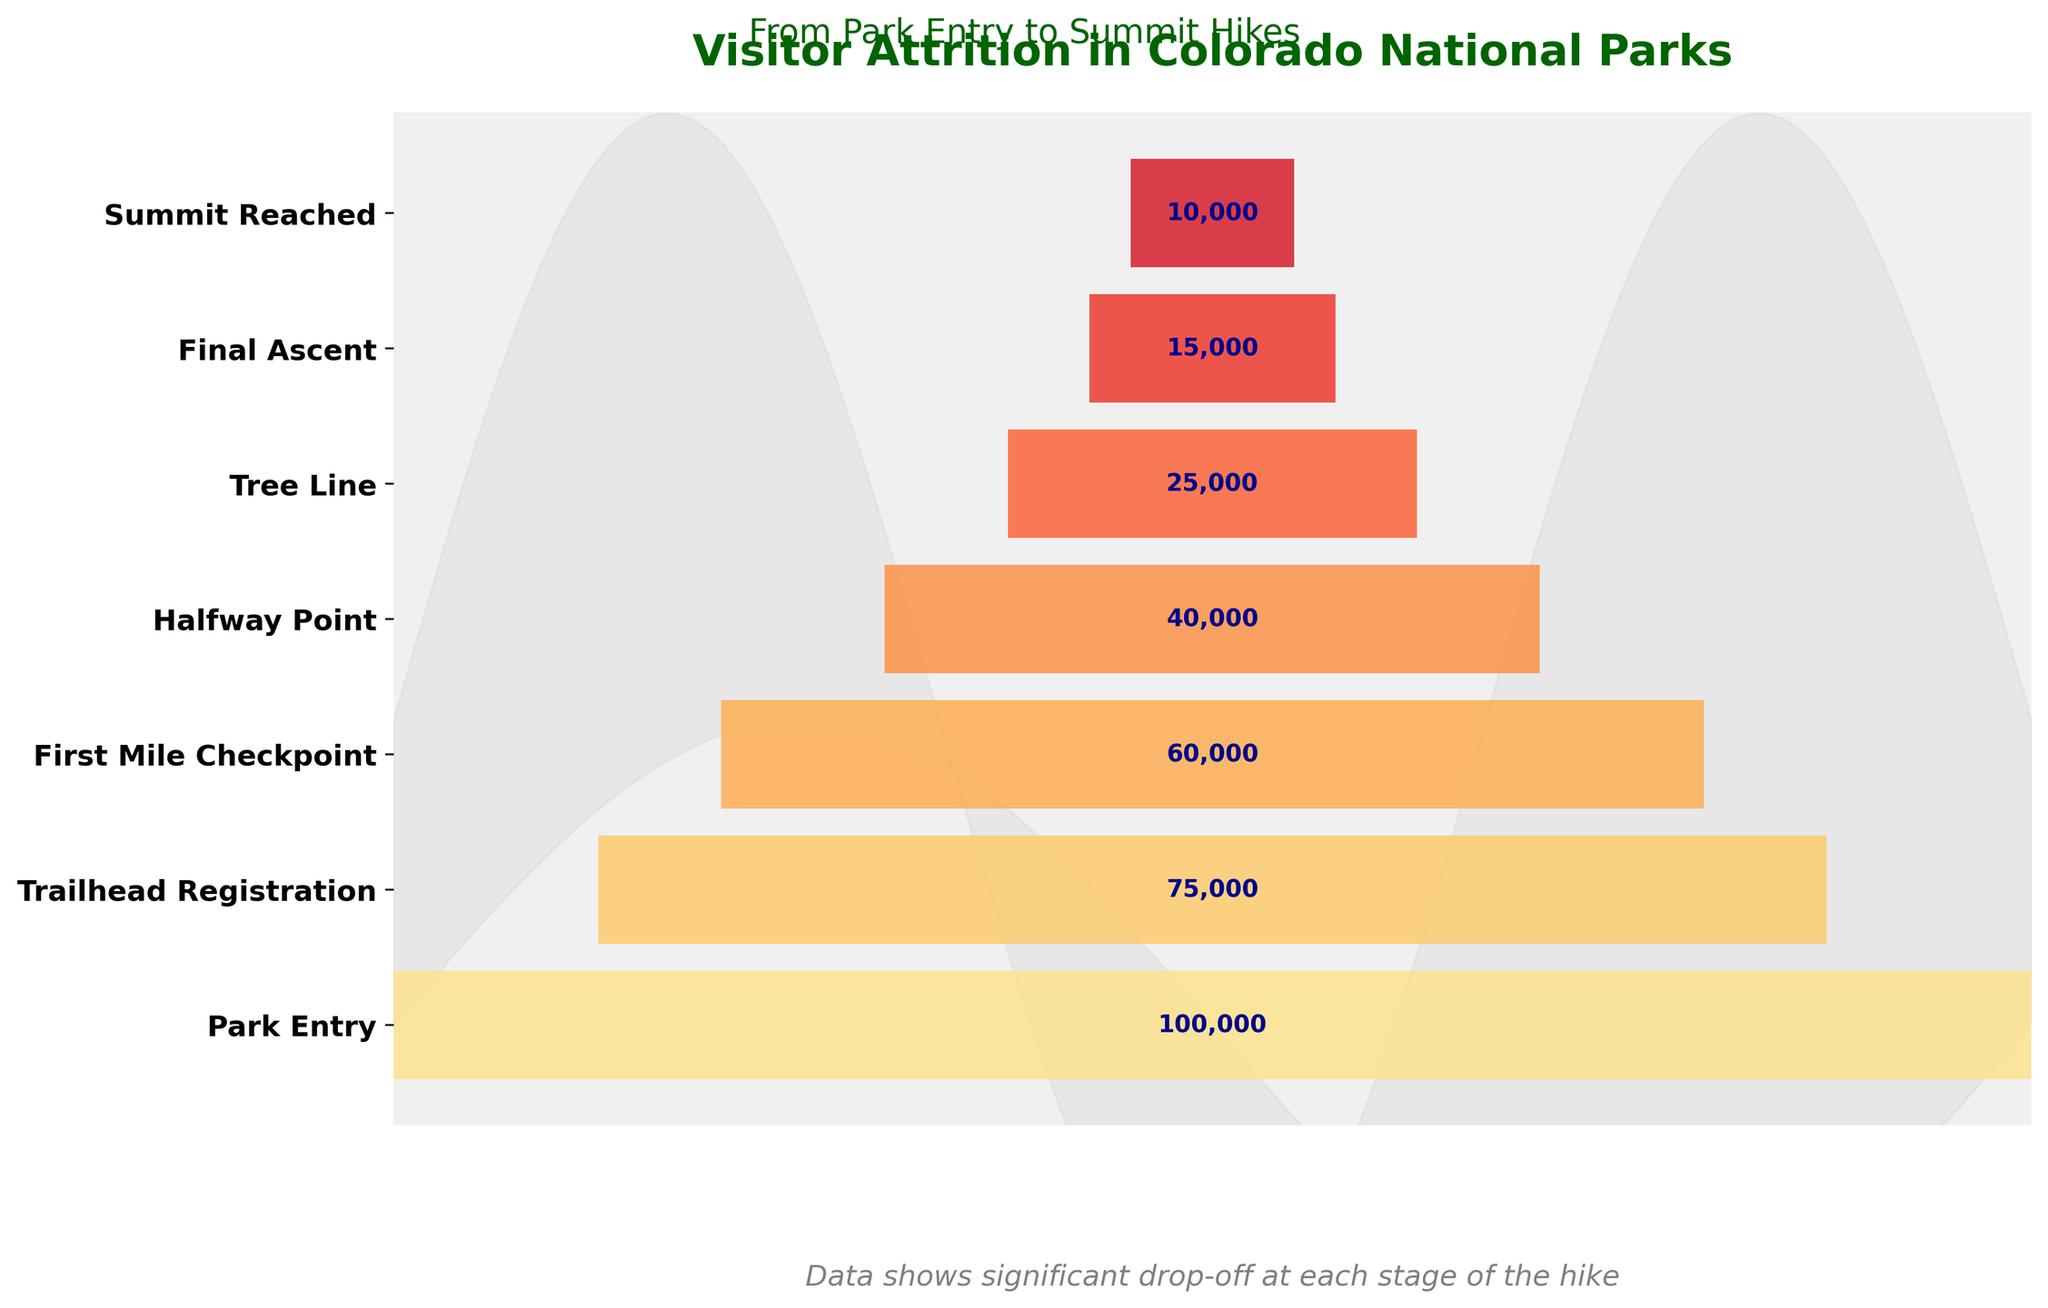What is the title of the funnel chart? The title is located at the top of the chart, usually in a larger and bolder font compared to other texts.
Answer: Visitor Attrition in Colorado National Parks How many stages are there from park entry to summit reached? The number of stages can be identified by counting the labeled sections along the vertical axis of the funnel chart.
Answer: 7 What percentage of visitors who registered at the trailhead reached the summit? First, identify the number of visitors at both the Trailhead Registration (75,000) and Summit Reached stages (10,000). Then, calculate the percentage: (10,000 / 75,000) * 100%.
Answer: 13.33% Which stage has the highest drop-off in visitor numbers? By observing the chart, we can see the stages and compare where the largest reduction is between consecutive stages. By the data, it is from the Tree Line to the Final Ascent (25,000 to 15,000).
Answer: Tree Line to Final Ascent What is the difference in the number of visitors between the Park Entry and the Summit Reached stages? Subtract the number of visitors at Summit Reached (10,000) from the number at Park Entry (100,000): 100,000 - 10,000.
Answer: 90,000 Compare the number of visitors at the Halfway Point and Tree Line. Which stage has more visitors? Look at the visitor numbers at both stages: Halfway Point (40,000) and Tree Line (25,000). Compare them directly.
Answer: Halfway Point How many visitors made it past the First Mile Checkpoint but did not reach the Tree Line? Subtract the number of visitors at Tree Line (25,000) from those at the First Mile Checkpoint (60,000): 60,000 - 25,000.
Answer: 35,000 What is the overall attrition rate from Park Entry to Summit Reached? Calculate the overall attrition by subtracting the number of visitors who reached the summit (10,000) from those who entered the park (100,000), then divide by the initial number and multiply by 100: ((100,000 - 10,000) / 100,000) * 100.
Answer: 90% What is the average number of visitors at each stage? Add the number of visitors at all stages and divide by the number of stages. The sum is 100,000 + 75,000 + 60,000 + 40,000 + 25,000 + 15,000 + 10,000 = 325,000. The number of stages is 7. 325,000 / 7.
Answer: 46,429 Which two consecutive stages have the smallest difference in visitor numbers? Compare the differences between consecutive stages: Park Entry to Trailhead Registration (25,000), Trailhead Registration to First Mile Checkpoint (15,000), First Mile Checkpoint to Halfway Point (20,000), Halfway Point to Tree Line (15,000), Tree Line to Final Ascent (10,000), Final Ascent to Summit Reached (5,000). The smallest difference is from Final Ascent to Summit Reached (5,000).
Answer: Final Ascent to Summit Reached 